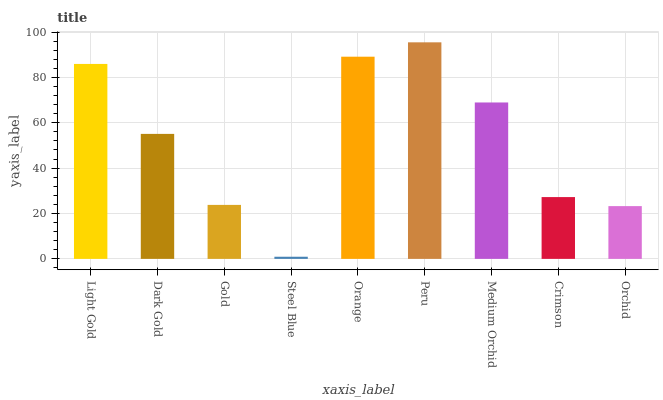Is Steel Blue the minimum?
Answer yes or no. Yes. Is Peru the maximum?
Answer yes or no. Yes. Is Dark Gold the minimum?
Answer yes or no. No. Is Dark Gold the maximum?
Answer yes or no. No. Is Light Gold greater than Dark Gold?
Answer yes or no. Yes. Is Dark Gold less than Light Gold?
Answer yes or no. Yes. Is Dark Gold greater than Light Gold?
Answer yes or no. No. Is Light Gold less than Dark Gold?
Answer yes or no. No. Is Dark Gold the high median?
Answer yes or no. Yes. Is Dark Gold the low median?
Answer yes or no. Yes. Is Peru the high median?
Answer yes or no. No. Is Orange the low median?
Answer yes or no. No. 